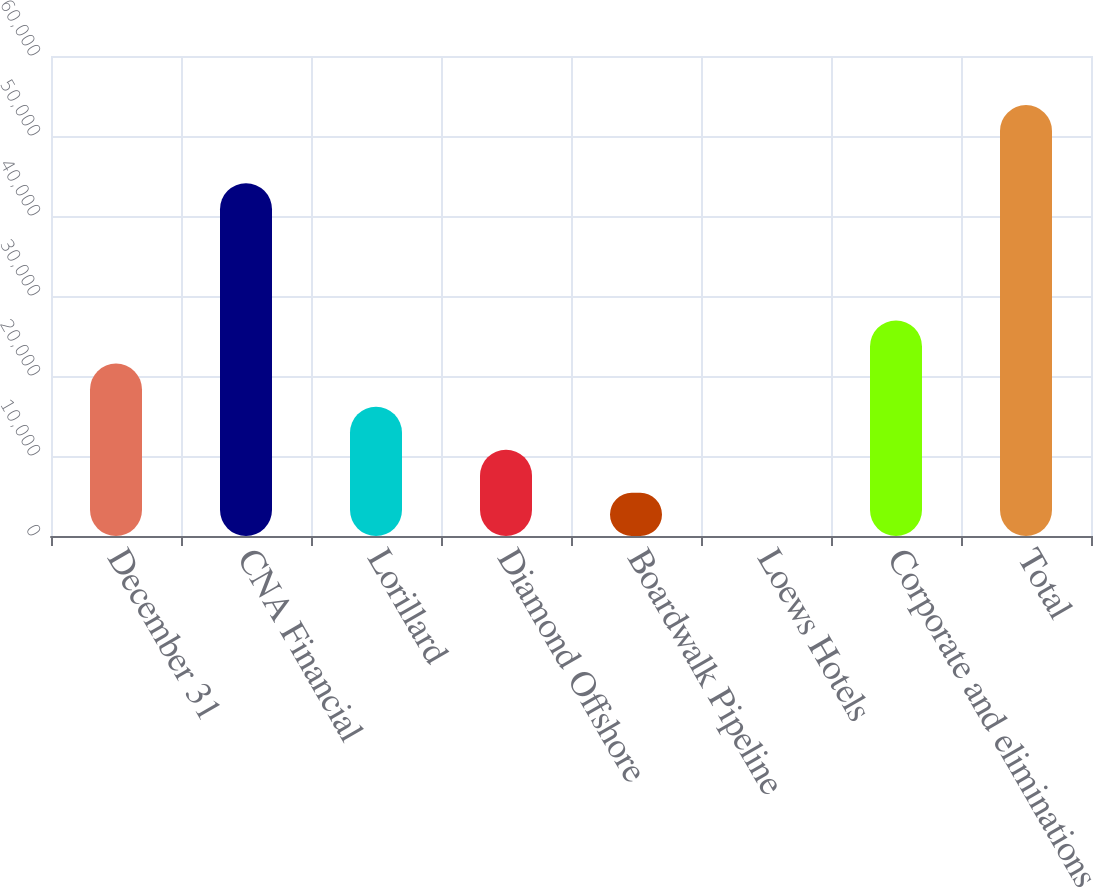Convert chart. <chart><loc_0><loc_0><loc_500><loc_500><bar_chart><fcel>December 31<fcel>CNA Financial<fcel>Lorillard<fcel>Diamond Offshore<fcel>Boardwalk Pipeline<fcel>Loews Hotels<fcel>Corporate and eliminations<fcel>Total<nl><fcel>21554<fcel>44094<fcel>16168<fcel>10782<fcel>5396<fcel>10<fcel>26940<fcel>53870<nl></chart> 